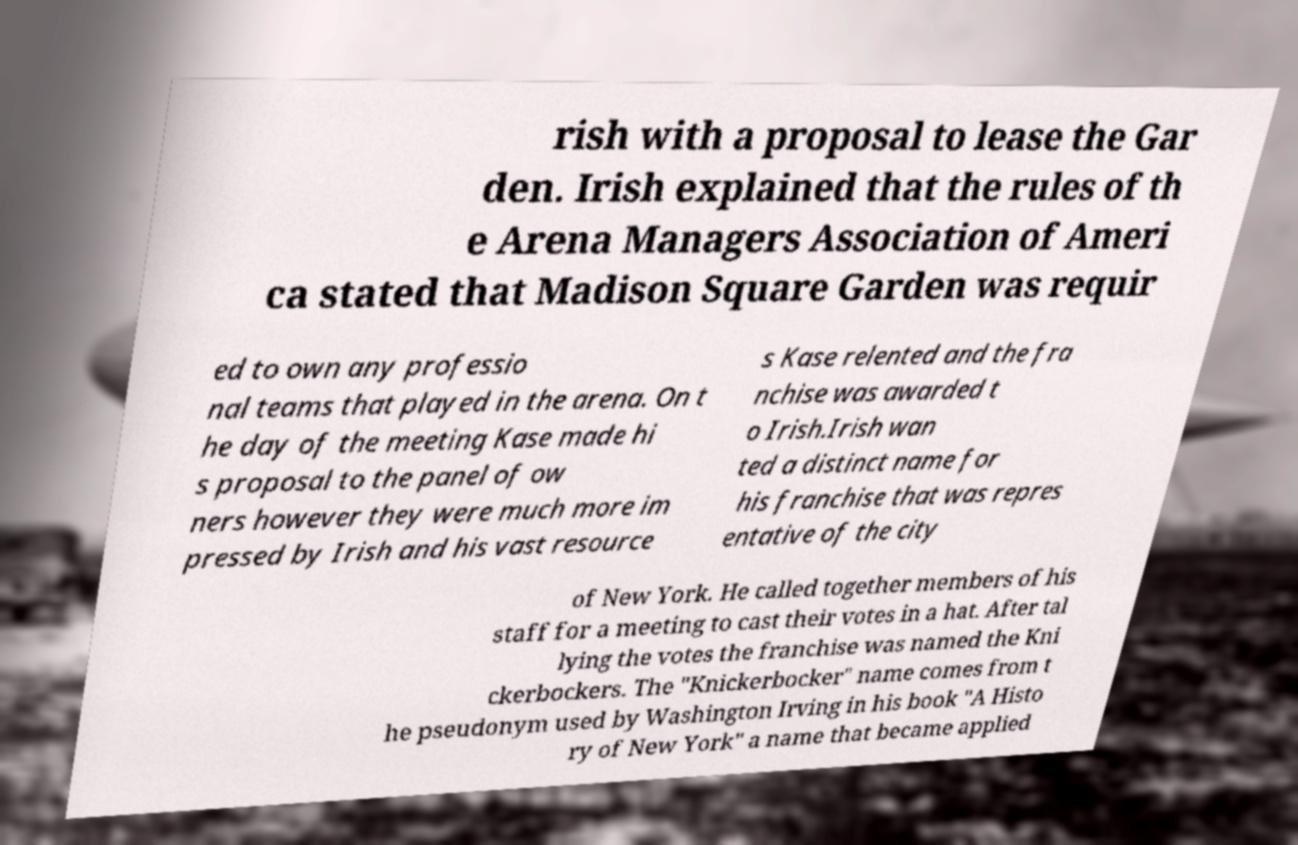Please identify and transcribe the text found in this image. rish with a proposal to lease the Gar den. Irish explained that the rules of th e Arena Managers Association of Ameri ca stated that Madison Square Garden was requir ed to own any professio nal teams that played in the arena. On t he day of the meeting Kase made hi s proposal to the panel of ow ners however they were much more im pressed by Irish and his vast resource s Kase relented and the fra nchise was awarded t o Irish.Irish wan ted a distinct name for his franchise that was repres entative of the city of New York. He called together members of his staff for a meeting to cast their votes in a hat. After tal lying the votes the franchise was named the Kni ckerbockers. The "Knickerbocker" name comes from t he pseudonym used by Washington Irving in his book "A Histo ry of New York" a name that became applied 